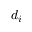<formula> <loc_0><loc_0><loc_500><loc_500>d _ { i }</formula> 